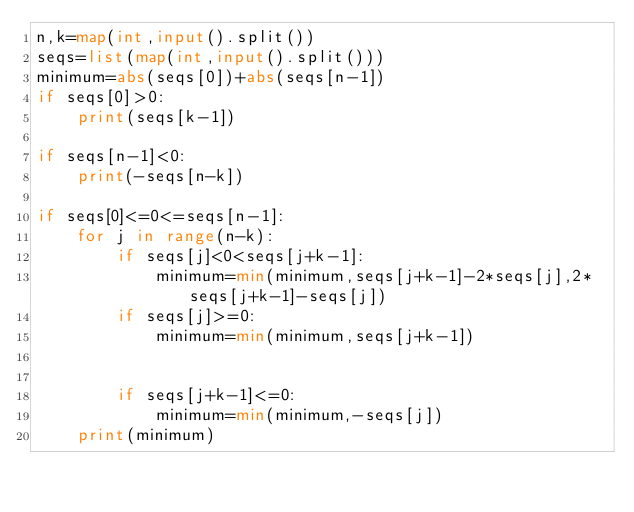Convert code to text. <code><loc_0><loc_0><loc_500><loc_500><_Python_>n,k=map(int,input().split())
seqs=list(map(int,input().split()))
minimum=abs(seqs[0])+abs(seqs[n-1])
if seqs[0]>0:
    print(seqs[k-1])
    
if seqs[n-1]<0:
    print(-seqs[n-k])
    
if seqs[0]<=0<=seqs[n-1]:
    for j in range(n-k):
        if seqs[j]<0<seqs[j+k-1]:
            minimum=min(minimum,seqs[j+k-1]-2*seqs[j],2*seqs[j+k-1]-seqs[j])
        if seqs[j]>=0:
            minimum=min(minimum,seqs[j+k-1])
        
        
        if seqs[j+k-1]<=0:
            minimum=min(minimum,-seqs[j])
    print(minimum)</code> 